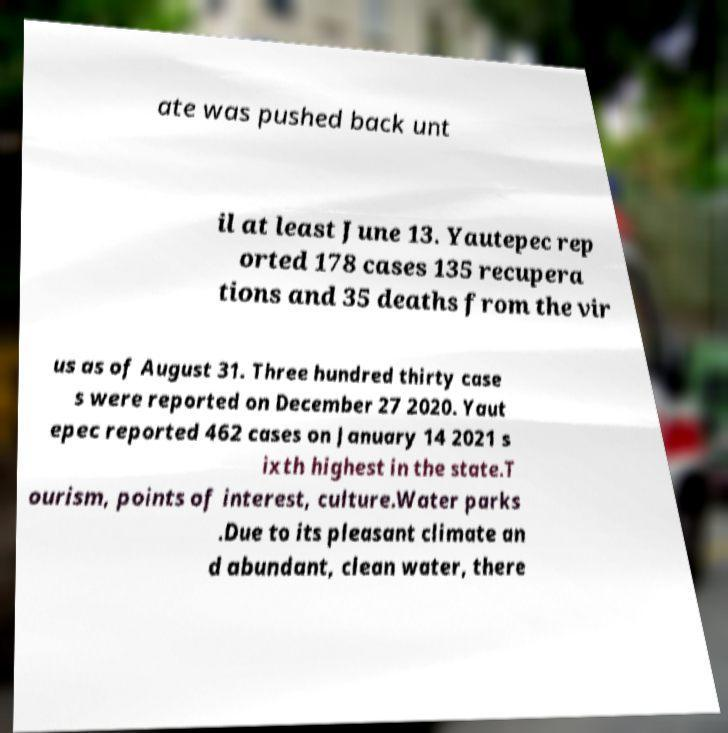There's text embedded in this image that I need extracted. Can you transcribe it verbatim? ate was pushed back unt il at least June 13. Yautepec rep orted 178 cases 135 recupera tions and 35 deaths from the vir us as of August 31. Three hundred thirty case s were reported on December 27 2020. Yaut epec reported 462 cases on January 14 2021 s ixth highest in the state.T ourism, points of interest, culture.Water parks .Due to its pleasant climate an d abundant, clean water, there 